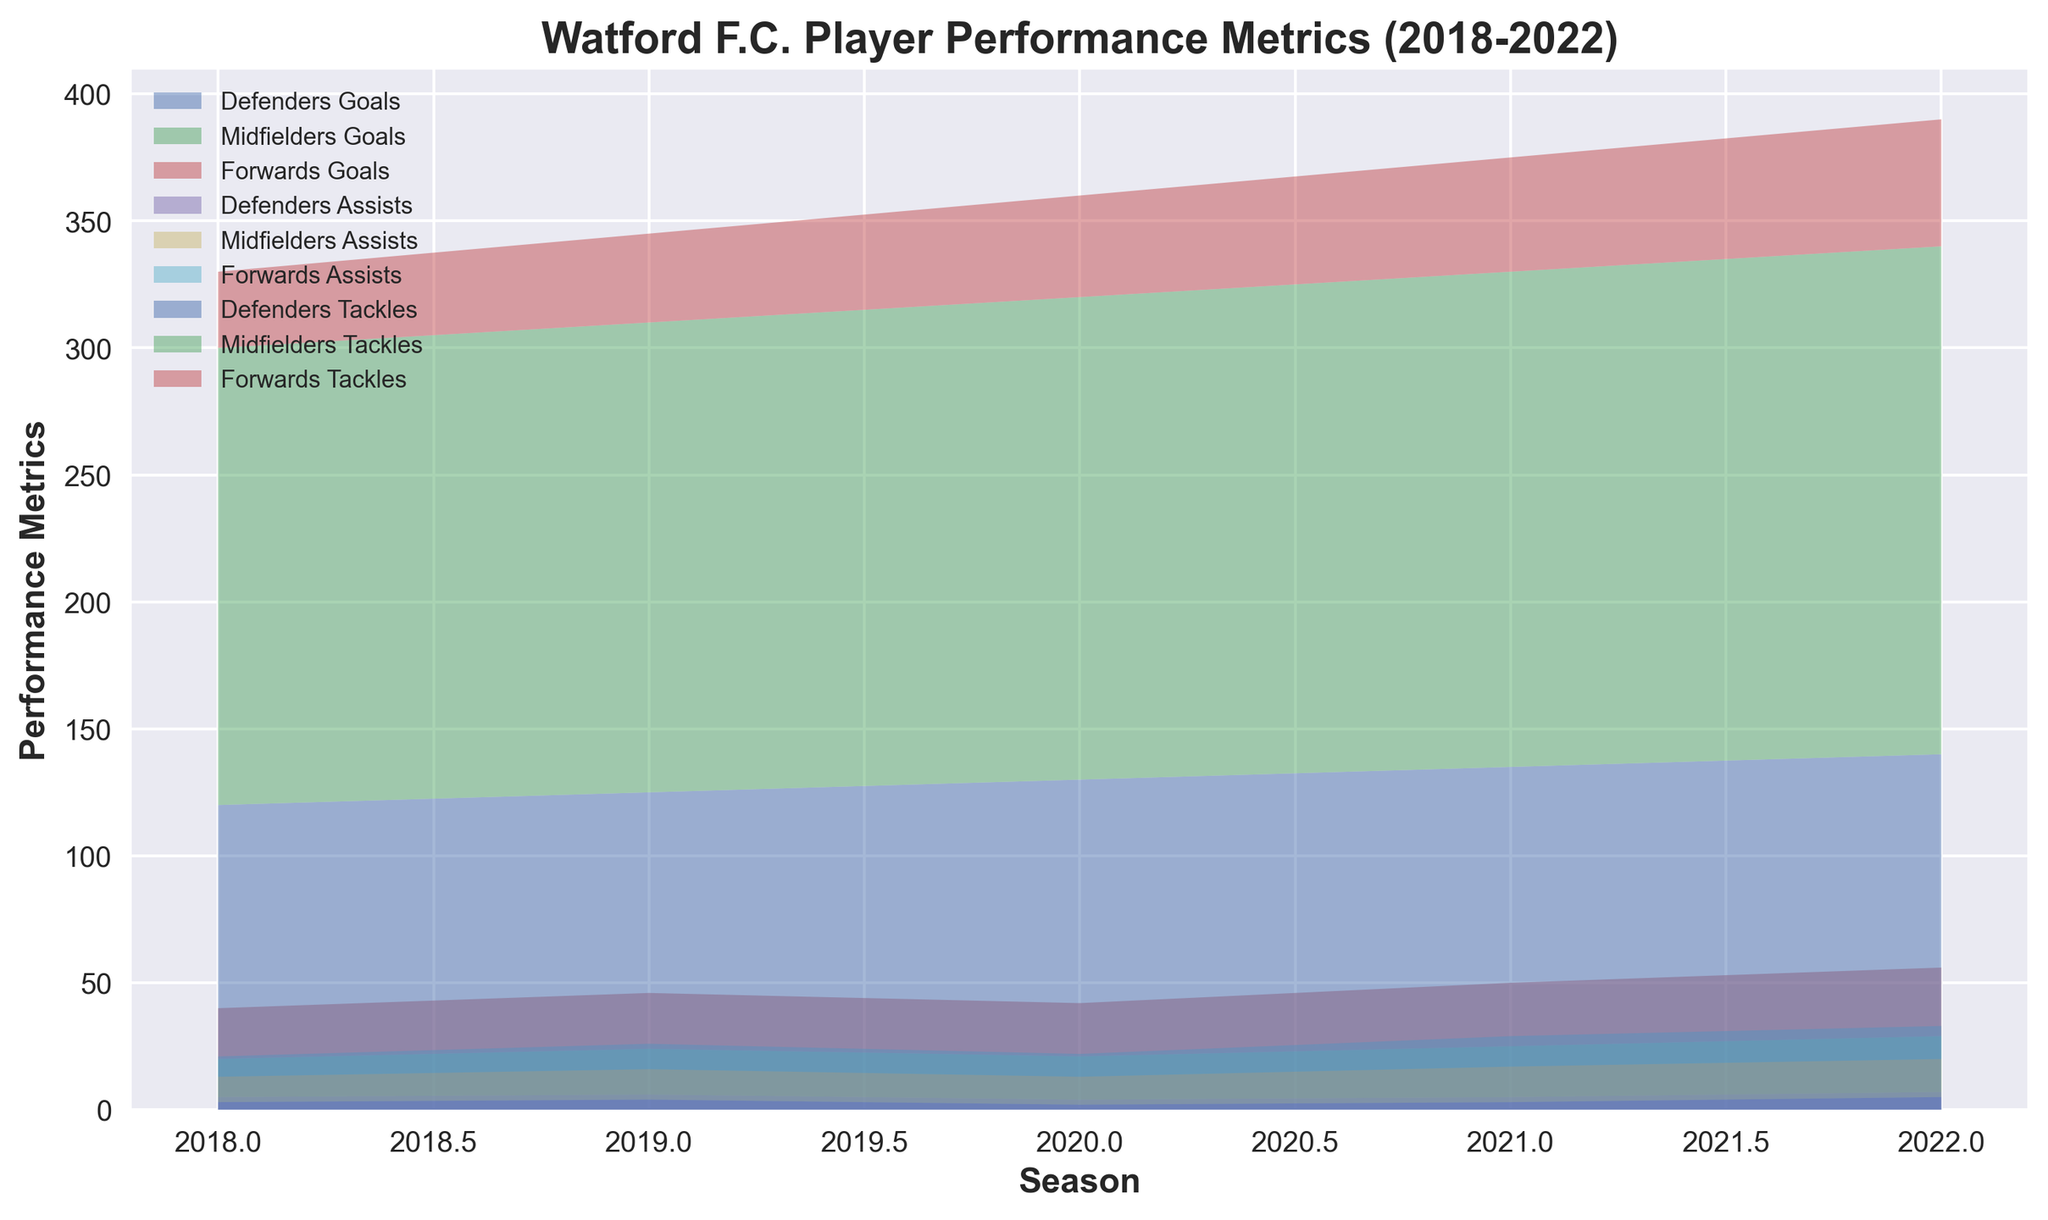What is the total number of goals scored by forwards over the five seasons? To find the total, we sum the goals scored by forwards for each season: 20 (2018) + 22 (2019) + 21 (2020) + 25 (2021) + 27 (2022) = 115
Answer: 115 Which position had the highest number of assists in the 2021 season? By examining the plot or data, we see that in 2021, defenders had 3 assists, midfielders had 14 assists, and forwards had 12 assists. Midfielders had the highest number of assists.
Answer: Midfielders In which season did defenders have their highest number of tackles? By checking the plot, we observe that defenders had the most tackles in 2022 with 140 tackles.
Answer: 2022 Did the number of goals scored by midfielders increase or decrease from 2018 to 2022? Observing the plot, the goals scored by midfielders increased from 15 in 2018 to 22 in 2022.
Answer: Increase What's the difference in the number of tackles between defenders and midfielders in 2020? In 2020, defenders made 130 tackles, and midfielders made 190 tackles. The difference is 190 - 130 = 60.
Answer: 60 Compare the number of goals scored by forwards and midfielders in 2019 and identify which position scored more. In 2019, the plot shows that forwards scored 22 goals while midfielders scored 18 goals. Forwards scored more goals.
Answer: Forwards What was the average number of assists made by midfielders over the five seasons? To calculate the average assists by midfielders: (10 + 12 + 11 + 14 + 15) / 5 = 62 / 5 = 12.4
Answer: 12.4 How did the number of goals scored by defenders change from 2018 to 2021? From the plot, we see that defenders scored 5 goals in 2018 and again 5 goals in 2021. The number of goals remained the same.
Answer: Remained the same Which position shows the most consistent number of tackles over the five seasons? Examining the plot, midfielders show a consistent increasing trend in tackles from 180 (2018) to 200 (2022), without any sharp spikes or declines.
Answer: Midfielders Across the five seasons, which position had the least variation in the number of assists? By observing the plot, defenders had the least variation in assists, with only minor changes from 3 (2018) to 5 (2022).
Answer: Defenders 